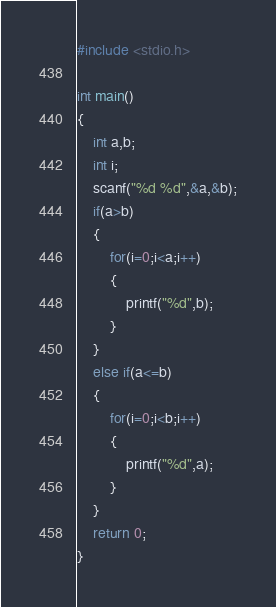Convert code to text. <code><loc_0><loc_0><loc_500><loc_500><_C_>#include <stdio.h>

int main()
{
    int a,b;
    int i;
    scanf("%d %d",&a,&b);
    if(a>b)
    {
        for(i=0;i<a;i++)
        {
            printf("%d",b);
        }
    }
    else if(a<=b)
    {
        for(i=0;i<b;i++)
        {
            printf("%d",a);
        }
    }
    return 0;
}</code> 